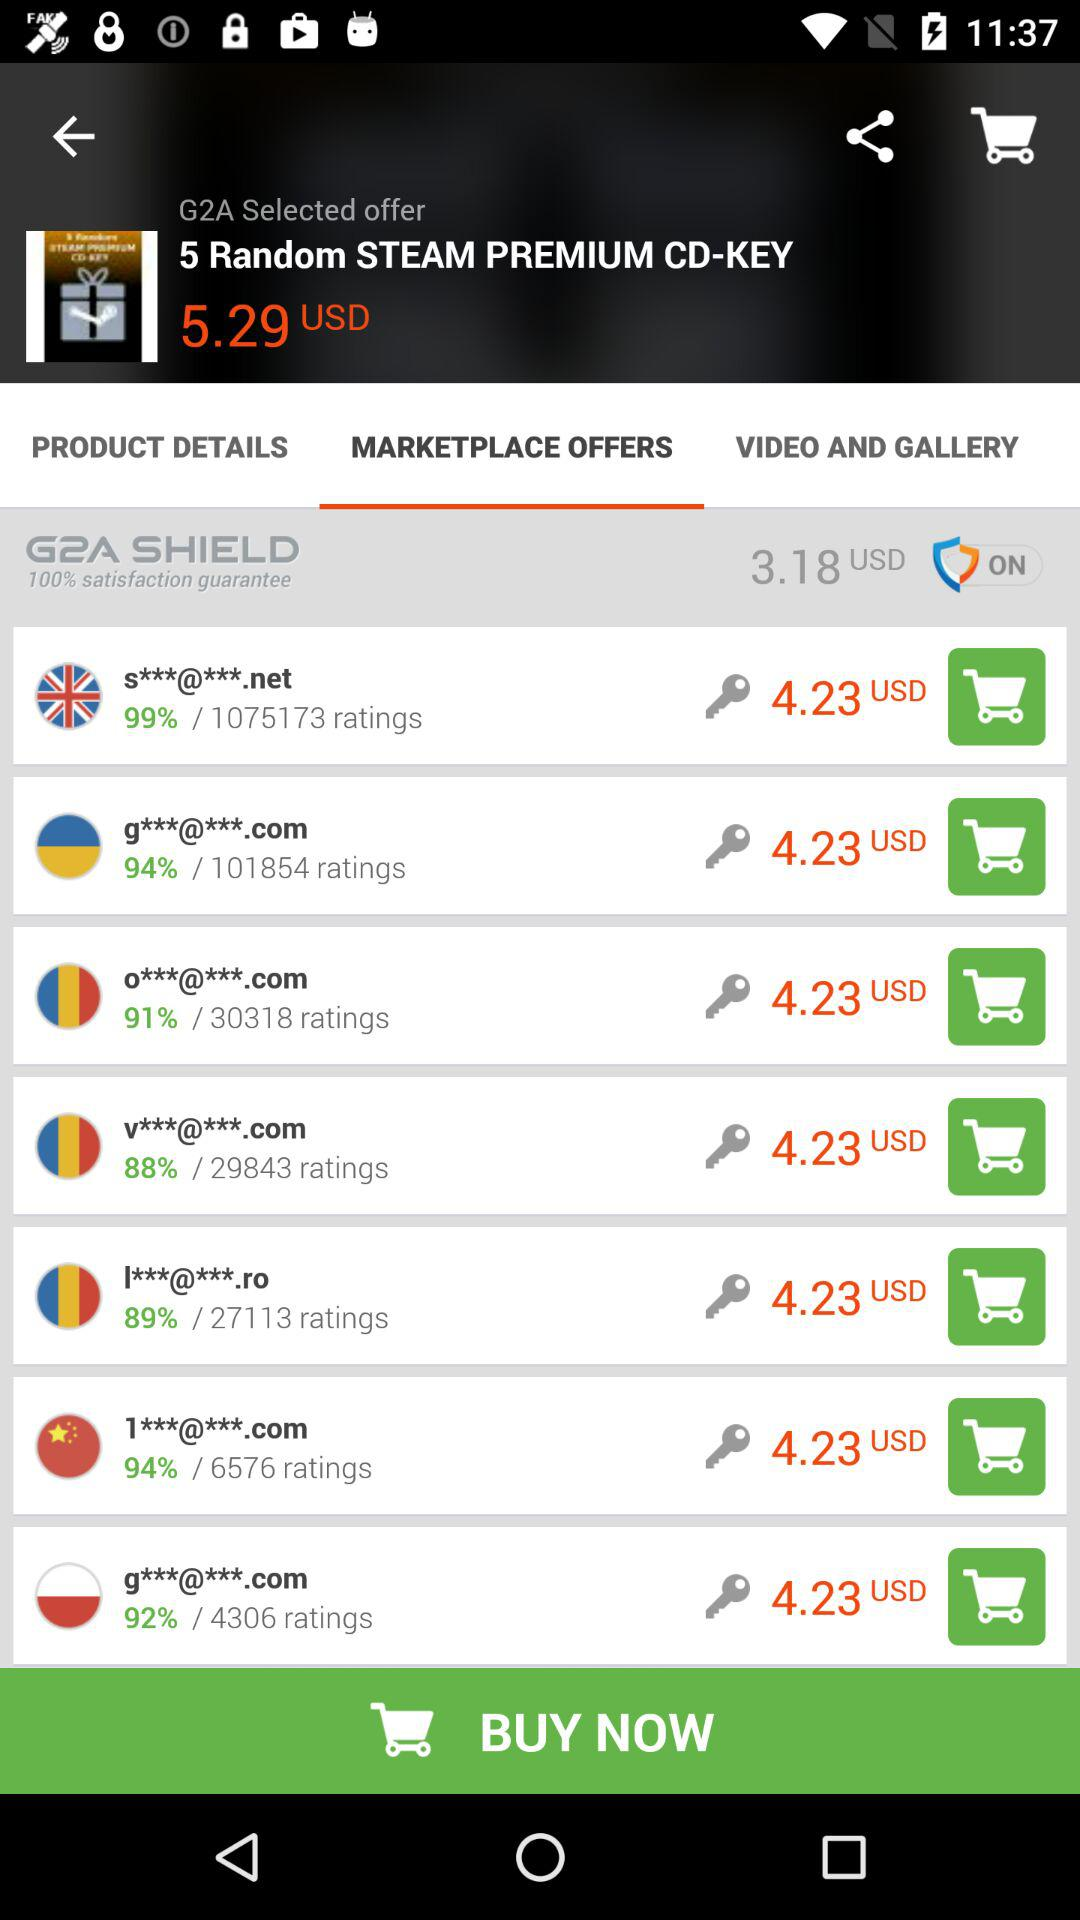What is the price asked by "v***@***.com"? The price asked by "v***@***.com" is 4.23 USD. 